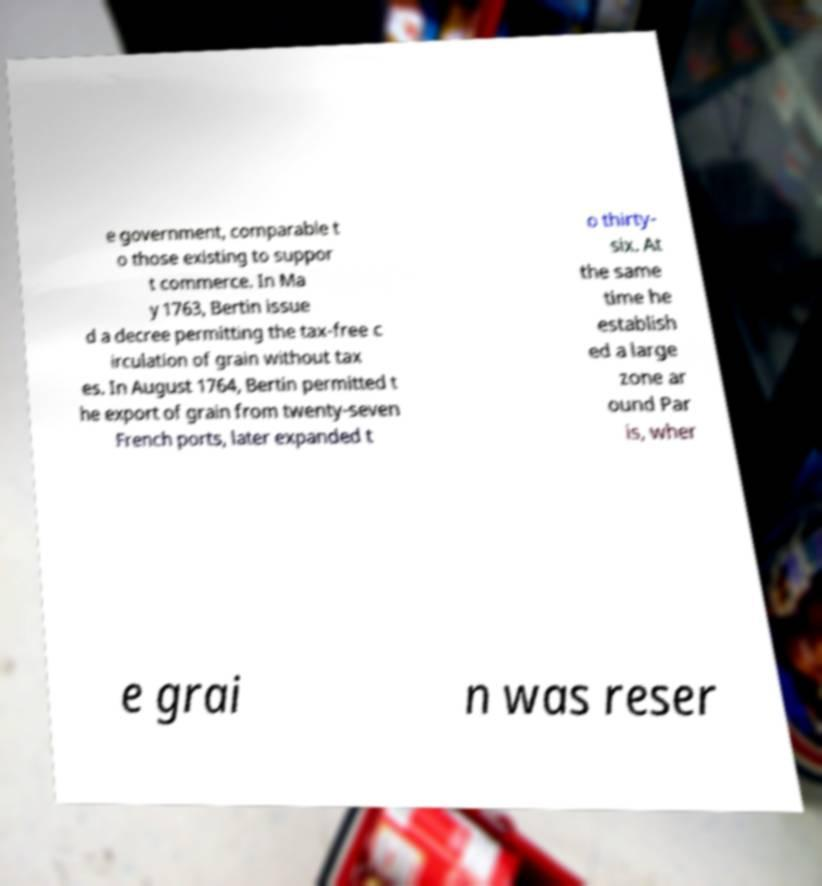For documentation purposes, I need the text within this image transcribed. Could you provide that? e government, comparable t o those existing to suppor t commerce. In Ma y 1763, Bertin issue d a decree permitting the tax-free c irculation of grain without tax es. In August 1764, Bertin permitted t he export of grain from twenty-seven French ports, later expanded t o thirty- six. At the same time he establish ed a large zone ar ound Par is, wher e grai n was reser 